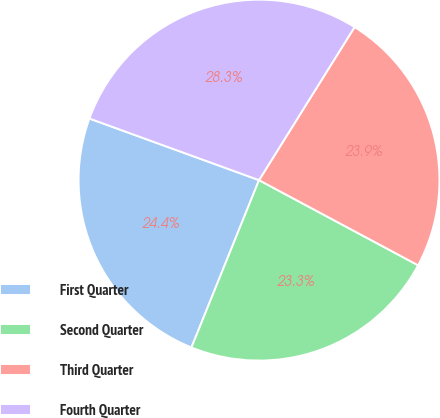Convert chart. <chart><loc_0><loc_0><loc_500><loc_500><pie_chart><fcel>First Quarter<fcel>Second Quarter<fcel>Third Quarter<fcel>Fourth Quarter<nl><fcel>24.44%<fcel>23.29%<fcel>23.94%<fcel>28.34%<nl></chart> 